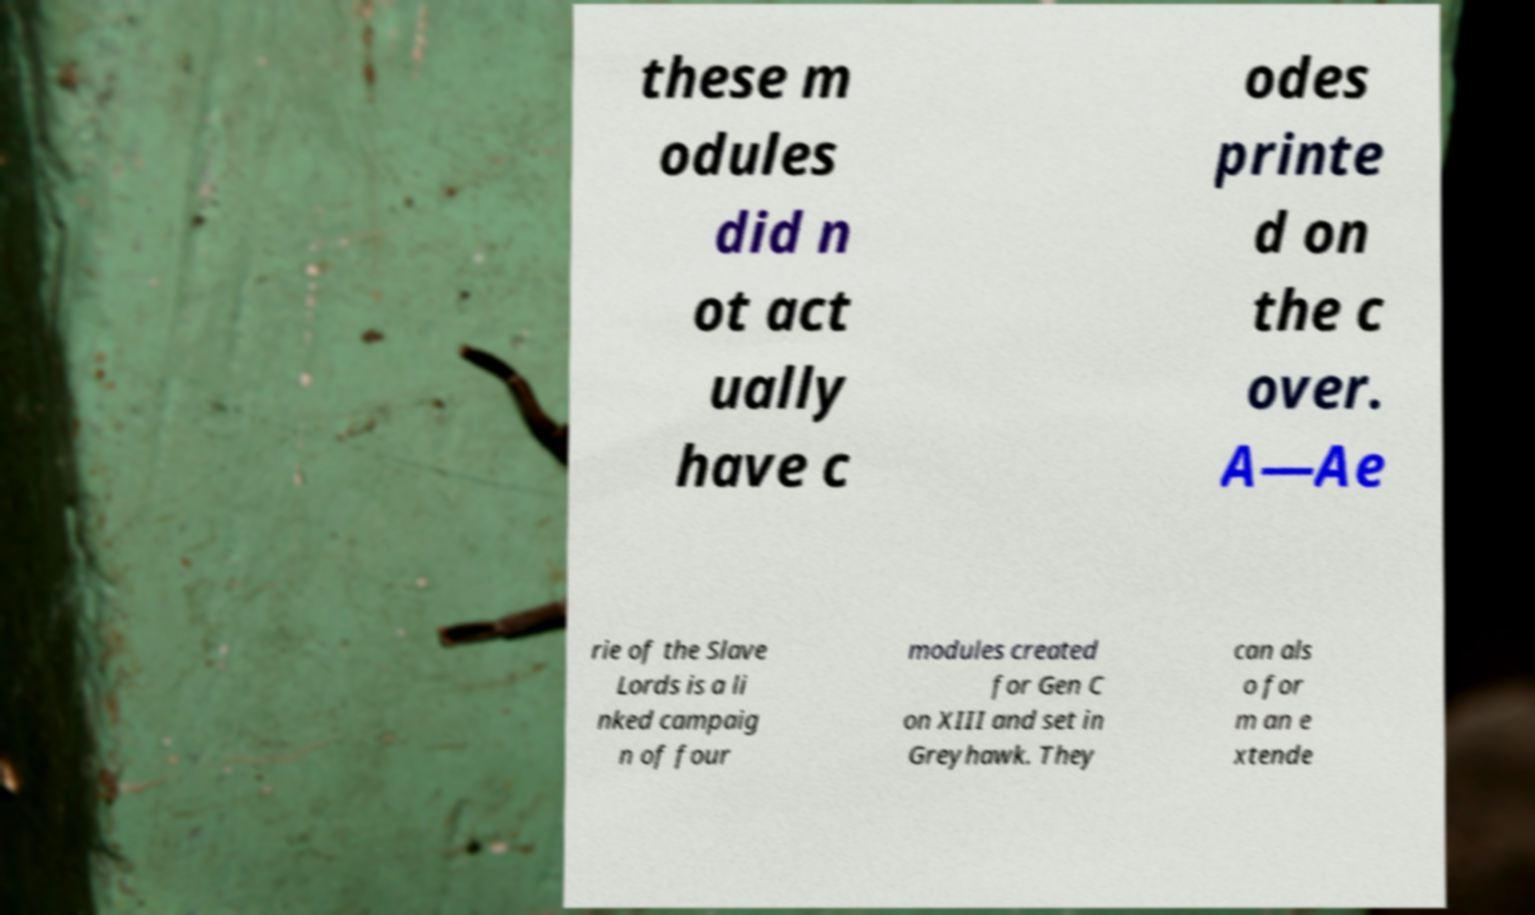Could you extract and type out the text from this image? these m odules did n ot act ually have c odes printe d on the c over. A—Ae rie of the Slave Lords is a li nked campaig n of four modules created for Gen C on XIII and set in Greyhawk. They can als o for m an e xtende 